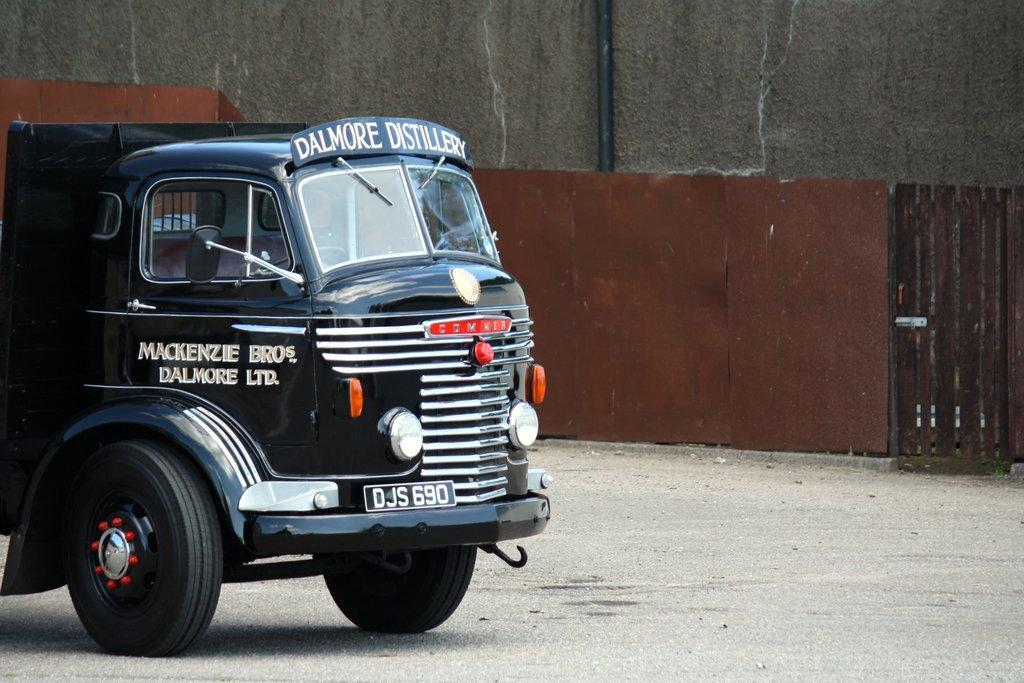What type of vehicle is in the image? There is a vehicle in the image, but the specific type is not mentioned. Where is the vehicle located in the image? The vehicle is on the ground in the image. What color is the vehicle? The vehicle is black in color. What can be seen in the background of the image? There is a wall and a gate in the background of the image. What type of legal advice is the vehicle seeking in the image? The image does not depict a vehicle seeking legal advice, as vehicles do not have the ability to seek legal advice. 